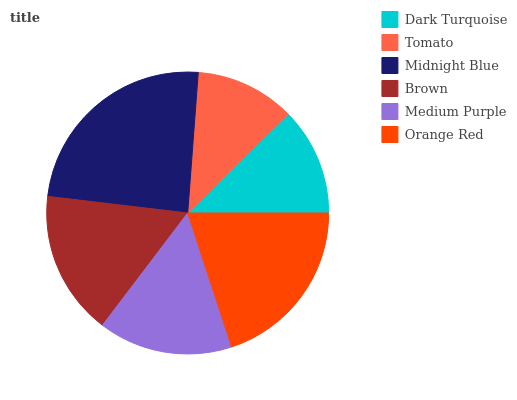Is Tomato the minimum?
Answer yes or no. Yes. Is Midnight Blue the maximum?
Answer yes or no. Yes. Is Midnight Blue the minimum?
Answer yes or no. No. Is Tomato the maximum?
Answer yes or no. No. Is Midnight Blue greater than Tomato?
Answer yes or no. Yes. Is Tomato less than Midnight Blue?
Answer yes or no. Yes. Is Tomato greater than Midnight Blue?
Answer yes or no. No. Is Midnight Blue less than Tomato?
Answer yes or no. No. Is Brown the high median?
Answer yes or no. Yes. Is Medium Purple the low median?
Answer yes or no. Yes. Is Medium Purple the high median?
Answer yes or no. No. Is Orange Red the low median?
Answer yes or no. No. 